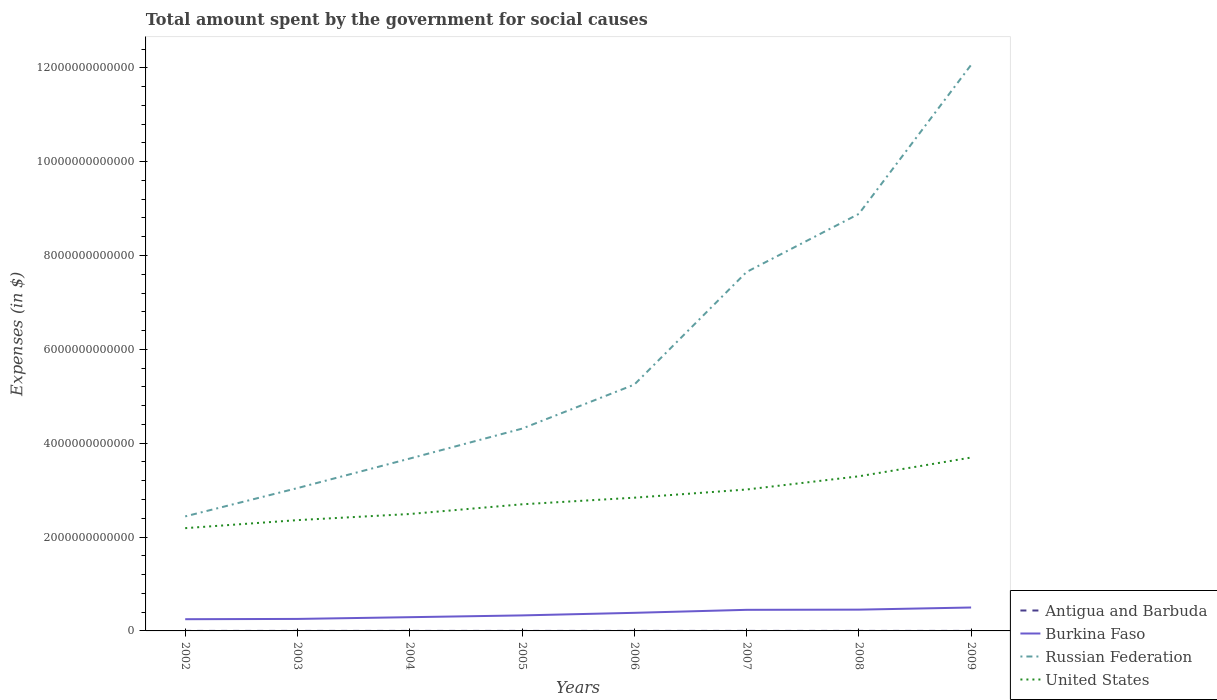How many different coloured lines are there?
Offer a very short reply. 4. Does the line corresponding to Russian Federation intersect with the line corresponding to Antigua and Barbuda?
Offer a very short reply. No. Across all years, what is the maximum amount spent for social causes by the government in Russian Federation?
Make the answer very short. 2.44e+12. What is the total amount spent for social causes by the government in United States in the graph?
Provide a short and direct response. -3.37e+11. What is the difference between the highest and the second highest amount spent for social causes by the government in Burkina Faso?
Your answer should be compact. 2.49e+11. Is the amount spent for social causes by the government in Antigua and Barbuda strictly greater than the amount spent for social causes by the government in United States over the years?
Make the answer very short. Yes. How many lines are there?
Provide a short and direct response. 4. What is the difference between two consecutive major ticks on the Y-axis?
Keep it short and to the point. 2.00e+12. Does the graph contain any zero values?
Make the answer very short. No. How many legend labels are there?
Ensure brevity in your answer.  4. How are the legend labels stacked?
Offer a terse response. Vertical. What is the title of the graph?
Keep it short and to the point. Total amount spent by the government for social causes. What is the label or title of the X-axis?
Your response must be concise. Years. What is the label or title of the Y-axis?
Your answer should be compact. Expenses (in $). What is the Expenses (in $) of Antigua and Barbuda in 2002?
Ensure brevity in your answer.  5.48e+08. What is the Expenses (in $) of Burkina Faso in 2002?
Give a very brief answer. 2.50e+11. What is the Expenses (in $) of Russian Federation in 2002?
Keep it short and to the point. 2.44e+12. What is the Expenses (in $) of United States in 2002?
Make the answer very short. 2.19e+12. What is the Expenses (in $) in Antigua and Barbuda in 2003?
Make the answer very short. 4.97e+08. What is the Expenses (in $) in Burkina Faso in 2003?
Make the answer very short. 2.56e+11. What is the Expenses (in $) in Russian Federation in 2003?
Provide a short and direct response. 3.04e+12. What is the Expenses (in $) in United States in 2003?
Offer a very short reply. 2.36e+12. What is the Expenses (in $) in Antigua and Barbuda in 2004?
Your answer should be compact. 5.53e+08. What is the Expenses (in $) of Burkina Faso in 2004?
Offer a terse response. 2.93e+11. What is the Expenses (in $) in Russian Federation in 2004?
Offer a terse response. 3.67e+12. What is the Expenses (in $) in United States in 2004?
Give a very brief answer. 2.49e+12. What is the Expenses (in $) in Antigua and Barbuda in 2005?
Your response must be concise. 5.63e+08. What is the Expenses (in $) in Burkina Faso in 2005?
Provide a succinct answer. 3.31e+11. What is the Expenses (in $) in Russian Federation in 2005?
Offer a very short reply. 4.31e+12. What is the Expenses (in $) in United States in 2005?
Provide a succinct answer. 2.70e+12. What is the Expenses (in $) in Antigua and Barbuda in 2006?
Make the answer very short. 6.84e+08. What is the Expenses (in $) of Burkina Faso in 2006?
Offer a terse response. 3.86e+11. What is the Expenses (in $) of Russian Federation in 2006?
Offer a very short reply. 5.25e+12. What is the Expenses (in $) of United States in 2006?
Give a very brief answer. 2.84e+12. What is the Expenses (in $) in Antigua and Barbuda in 2007?
Provide a short and direct response. 7.50e+08. What is the Expenses (in $) in Burkina Faso in 2007?
Give a very brief answer. 4.49e+11. What is the Expenses (in $) of Russian Federation in 2007?
Your response must be concise. 7.65e+12. What is the Expenses (in $) in United States in 2007?
Your answer should be compact. 3.01e+12. What is the Expenses (in $) in Antigua and Barbuda in 2008?
Provide a short and direct response. 7.66e+08. What is the Expenses (in $) of Burkina Faso in 2008?
Your answer should be very brief. 4.54e+11. What is the Expenses (in $) in Russian Federation in 2008?
Keep it short and to the point. 8.89e+12. What is the Expenses (in $) in United States in 2008?
Your answer should be very brief. 3.30e+12. What is the Expenses (in $) in Antigua and Barbuda in 2009?
Your response must be concise. 7.82e+08. What is the Expenses (in $) in Burkina Faso in 2009?
Provide a succinct answer. 4.99e+11. What is the Expenses (in $) of Russian Federation in 2009?
Provide a short and direct response. 1.21e+13. What is the Expenses (in $) of United States in 2009?
Make the answer very short. 3.70e+12. Across all years, what is the maximum Expenses (in $) of Antigua and Barbuda?
Provide a succinct answer. 7.82e+08. Across all years, what is the maximum Expenses (in $) in Burkina Faso?
Keep it short and to the point. 4.99e+11. Across all years, what is the maximum Expenses (in $) of Russian Federation?
Make the answer very short. 1.21e+13. Across all years, what is the maximum Expenses (in $) of United States?
Offer a terse response. 3.70e+12. Across all years, what is the minimum Expenses (in $) in Antigua and Barbuda?
Give a very brief answer. 4.97e+08. Across all years, what is the minimum Expenses (in $) in Burkina Faso?
Ensure brevity in your answer.  2.50e+11. Across all years, what is the minimum Expenses (in $) of Russian Federation?
Your response must be concise. 2.44e+12. Across all years, what is the minimum Expenses (in $) in United States?
Your answer should be compact. 2.19e+12. What is the total Expenses (in $) in Antigua and Barbuda in the graph?
Offer a very short reply. 5.14e+09. What is the total Expenses (in $) in Burkina Faso in the graph?
Make the answer very short. 2.92e+12. What is the total Expenses (in $) in Russian Federation in the graph?
Give a very brief answer. 4.73e+13. What is the total Expenses (in $) of United States in the graph?
Offer a very short reply. 2.26e+13. What is the difference between the Expenses (in $) of Antigua and Barbuda in 2002 and that in 2003?
Provide a short and direct response. 5.01e+07. What is the difference between the Expenses (in $) in Burkina Faso in 2002 and that in 2003?
Offer a very short reply. -5.97e+09. What is the difference between the Expenses (in $) of Russian Federation in 2002 and that in 2003?
Give a very brief answer. -6.03e+11. What is the difference between the Expenses (in $) in United States in 2002 and that in 2003?
Make the answer very short. -1.71e+11. What is the difference between the Expenses (in $) of Antigua and Barbuda in 2002 and that in 2004?
Give a very brief answer. -5.50e+06. What is the difference between the Expenses (in $) in Burkina Faso in 2002 and that in 2004?
Offer a very short reply. -4.28e+1. What is the difference between the Expenses (in $) in Russian Federation in 2002 and that in 2004?
Provide a short and direct response. -1.23e+12. What is the difference between the Expenses (in $) of United States in 2002 and that in 2004?
Offer a terse response. -3.02e+11. What is the difference between the Expenses (in $) in Antigua and Barbuda in 2002 and that in 2005?
Provide a short and direct response. -1.58e+07. What is the difference between the Expenses (in $) in Burkina Faso in 2002 and that in 2005?
Offer a terse response. -8.08e+1. What is the difference between the Expenses (in $) in Russian Federation in 2002 and that in 2005?
Make the answer very short. -1.87e+12. What is the difference between the Expenses (in $) of United States in 2002 and that in 2005?
Give a very brief answer. -5.08e+11. What is the difference between the Expenses (in $) in Antigua and Barbuda in 2002 and that in 2006?
Your answer should be very brief. -1.37e+08. What is the difference between the Expenses (in $) in Burkina Faso in 2002 and that in 2006?
Offer a very short reply. -1.36e+11. What is the difference between the Expenses (in $) in Russian Federation in 2002 and that in 2006?
Offer a terse response. -2.81e+12. What is the difference between the Expenses (in $) of United States in 2002 and that in 2006?
Offer a terse response. -6.49e+11. What is the difference between the Expenses (in $) of Antigua and Barbuda in 2002 and that in 2007?
Keep it short and to the point. -2.02e+08. What is the difference between the Expenses (in $) of Burkina Faso in 2002 and that in 2007?
Offer a very short reply. -2.00e+11. What is the difference between the Expenses (in $) in Russian Federation in 2002 and that in 2007?
Your response must be concise. -5.21e+12. What is the difference between the Expenses (in $) in United States in 2002 and that in 2007?
Your answer should be very brief. -8.24e+11. What is the difference between the Expenses (in $) in Antigua and Barbuda in 2002 and that in 2008?
Your answer should be compact. -2.19e+08. What is the difference between the Expenses (in $) in Burkina Faso in 2002 and that in 2008?
Your answer should be very brief. -2.04e+11. What is the difference between the Expenses (in $) of Russian Federation in 2002 and that in 2008?
Offer a terse response. -6.45e+12. What is the difference between the Expenses (in $) in United States in 2002 and that in 2008?
Offer a terse response. -1.11e+12. What is the difference between the Expenses (in $) of Antigua and Barbuda in 2002 and that in 2009?
Offer a very short reply. -2.34e+08. What is the difference between the Expenses (in $) of Burkina Faso in 2002 and that in 2009?
Provide a short and direct response. -2.49e+11. What is the difference between the Expenses (in $) of Russian Federation in 2002 and that in 2009?
Keep it short and to the point. -9.62e+12. What is the difference between the Expenses (in $) in United States in 2002 and that in 2009?
Your answer should be compact. -1.50e+12. What is the difference between the Expenses (in $) in Antigua and Barbuda in 2003 and that in 2004?
Give a very brief answer. -5.56e+07. What is the difference between the Expenses (in $) of Burkina Faso in 2003 and that in 2004?
Provide a short and direct response. -3.68e+1. What is the difference between the Expenses (in $) of Russian Federation in 2003 and that in 2004?
Your response must be concise. -6.29e+11. What is the difference between the Expenses (in $) of United States in 2003 and that in 2004?
Provide a short and direct response. -1.30e+11. What is the difference between the Expenses (in $) in Antigua and Barbuda in 2003 and that in 2005?
Offer a terse response. -6.59e+07. What is the difference between the Expenses (in $) in Burkina Faso in 2003 and that in 2005?
Offer a very short reply. -7.48e+1. What is the difference between the Expenses (in $) in Russian Federation in 2003 and that in 2005?
Provide a short and direct response. -1.27e+12. What is the difference between the Expenses (in $) in United States in 2003 and that in 2005?
Your answer should be very brief. -3.37e+11. What is the difference between the Expenses (in $) in Antigua and Barbuda in 2003 and that in 2006?
Provide a short and direct response. -1.87e+08. What is the difference between the Expenses (in $) in Burkina Faso in 2003 and that in 2006?
Your answer should be compact. -1.30e+11. What is the difference between the Expenses (in $) in Russian Federation in 2003 and that in 2006?
Your answer should be very brief. -2.20e+12. What is the difference between the Expenses (in $) of United States in 2003 and that in 2006?
Provide a succinct answer. -4.78e+11. What is the difference between the Expenses (in $) in Antigua and Barbuda in 2003 and that in 2007?
Keep it short and to the point. -2.52e+08. What is the difference between the Expenses (in $) in Burkina Faso in 2003 and that in 2007?
Your answer should be compact. -1.94e+11. What is the difference between the Expenses (in $) in Russian Federation in 2003 and that in 2007?
Your response must be concise. -4.61e+12. What is the difference between the Expenses (in $) of United States in 2003 and that in 2007?
Offer a very short reply. -6.53e+11. What is the difference between the Expenses (in $) of Antigua and Barbuda in 2003 and that in 2008?
Ensure brevity in your answer.  -2.69e+08. What is the difference between the Expenses (in $) of Burkina Faso in 2003 and that in 2008?
Offer a terse response. -1.98e+11. What is the difference between the Expenses (in $) in Russian Federation in 2003 and that in 2008?
Your answer should be very brief. -5.84e+12. What is the difference between the Expenses (in $) of United States in 2003 and that in 2008?
Offer a terse response. -9.34e+11. What is the difference between the Expenses (in $) of Antigua and Barbuda in 2003 and that in 2009?
Your answer should be compact. -2.84e+08. What is the difference between the Expenses (in $) in Burkina Faso in 2003 and that in 2009?
Offer a very short reply. -2.43e+11. What is the difference between the Expenses (in $) of Russian Federation in 2003 and that in 2009?
Make the answer very short. -9.02e+12. What is the difference between the Expenses (in $) of United States in 2003 and that in 2009?
Provide a short and direct response. -1.33e+12. What is the difference between the Expenses (in $) in Antigua and Barbuda in 2004 and that in 2005?
Offer a terse response. -1.03e+07. What is the difference between the Expenses (in $) of Burkina Faso in 2004 and that in 2005?
Offer a very short reply. -3.80e+1. What is the difference between the Expenses (in $) of Russian Federation in 2004 and that in 2005?
Make the answer very short. -6.37e+11. What is the difference between the Expenses (in $) in United States in 2004 and that in 2005?
Offer a very short reply. -2.07e+11. What is the difference between the Expenses (in $) of Antigua and Barbuda in 2004 and that in 2006?
Offer a very short reply. -1.31e+08. What is the difference between the Expenses (in $) in Burkina Faso in 2004 and that in 2006?
Provide a short and direct response. -9.30e+1. What is the difference between the Expenses (in $) in Russian Federation in 2004 and that in 2006?
Provide a short and direct response. -1.58e+12. What is the difference between the Expenses (in $) in United States in 2004 and that in 2006?
Your response must be concise. -3.48e+11. What is the difference between the Expenses (in $) in Antigua and Barbuda in 2004 and that in 2007?
Provide a short and direct response. -1.97e+08. What is the difference between the Expenses (in $) in Burkina Faso in 2004 and that in 2007?
Your response must be concise. -1.57e+11. What is the difference between the Expenses (in $) of Russian Federation in 2004 and that in 2007?
Your answer should be very brief. -3.98e+12. What is the difference between the Expenses (in $) of United States in 2004 and that in 2007?
Offer a very short reply. -5.22e+11. What is the difference between the Expenses (in $) of Antigua and Barbuda in 2004 and that in 2008?
Provide a short and direct response. -2.13e+08. What is the difference between the Expenses (in $) of Burkina Faso in 2004 and that in 2008?
Provide a succinct answer. -1.61e+11. What is the difference between the Expenses (in $) of Russian Federation in 2004 and that in 2008?
Make the answer very short. -5.21e+12. What is the difference between the Expenses (in $) of United States in 2004 and that in 2008?
Your answer should be very brief. -8.04e+11. What is the difference between the Expenses (in $) of Antigua and Barbuda in 2004 and that in 2009?
Provide a succinct answer. -2.29e+08. What is the difference between the Expenses (in $) in Burkina Faso in 2004 and that in 2009?
Make the answer very short. -2.06e+11. What is the difference between the Expenses (in $) of Russian Federation in 2004 and that in 2009?
Offer a very short reply. -8.39e+12. What is the difference between the Expenses (in $) in United States in 2004 and that in 2009?
Ensure brevity in your answer.  -1.20e+12. What is the difference between the Expenses (in $) in Antigua and Barbuda in 2005 and that in 2006?
Give a very brief answer. -1.21e+08. What is the difference between the Expenses (in $) of Burkina Faso in 2005 and that in 2006?
Your response must be concise. -5.50e+1. What is the difference between the Expenses (in $) of Russian Federation in 2005 and that in 2006?
Make the answer very short. -9.38e+11. What is the difference between the Expenses (in $) in United States in 2005 and that in 2006?
Your answer should be compact. -1.41e+11. What is the difference between the Expenses (in $) of Antigua and Barbuda in 2005 and that in 2007?
Provide a short and direct response. -1.86e+08. What is the difference between the Expenses (in $) in Burkina Faso in 2005 and that in 2007?
Your response must be concise. -1.19e+11. What is the difference between the Expenses (in $) in Russian Federation in 2005 and that in 2007?
Offer a terse response. -3.34e+12. What is the difference between the Expenses (in $) in United States in 2005 and that in 2007?
Keep it short and to the point. -3.15e+11. What is the difference between the Expenses (in $) of Antigua and Barbuda in 2005 and that in 2008?
Offer a terse response. -2.03e+08. What is the difference between the Expenses (in $) of Burkina Faso in 2005 and that in 2008?
Ensure brevity in your answer.  -1.23e+11. What is the difference between the Expenses (in $) in Russian Federation in 2005 and that in 2008?
Give a very brief answer. -4.58e+12. What is the difference between the Expenses (in $) of United States in 2005 and that in 2008?
Provide a short and direct response. -5.97e+11. What is the difference between the Expenses (in $) of Antigua and Barbuda in 2005 and that in 2009?
Give a very brief answer. -2.18e+08. What is the difference between the Expenses (in $) of Burkina Faso in 2005 and that in 2009?
Offer a terse response. -1.68e+11. What is the difference between the Expenses (in $) of Russian Federation in 2005 and that in 2009?
Give a very brief answer. -7.75e+12. What is the difference between the Expenses (in $) in United States in 2005 and that in 2009?
Your answer should be very brief. -9.97e+11. What is the difference between the Expenses (in $) of Antigua and Barbuda in 2006 and that in 2007?
Ensure brevity in your answer.  -6.55e+07. What is the difference between the Expenses (in $) in Burkina Faso in 2006 and that in 2007?
Your answer should be very brief. -6.37e+1. What is the difference between the Expenses (in $) in Russian Federation in 2006 and that in 2007?
Offer a very short reply. -2.40e+12. What is the difference between the Expenses (in $) in United States in 2006 and that in 2007?
Make the answer very short. -1.74e+11. What is the difference between the Expenses (in $) of Antigua and Barbuda in 2006 and that in 2008?
Ensure brevity in your answer.  -8.22e+07. What is the difference between the Expenses (in $) in Burkina Faso in 2006 and that in 2008?
Offer a terse response. -6.80e+1. What is the difference between the Expenses (in $) in Russian Federation in 2006 and that in 2008?
Give a very brief answer. -3.64e+12. What is the difference between the Expenses (in $) of United States in 2006 and that in 2008?
Your answer should be very brief. -4.56e+11. What is the difference between the Expenses (in $) in Antigua and Barbuda in 2006 and that in 2009?
Provide a succinct answer. -9.76e+07. What is the difference between the Expenses (in $) in Burkina Faso in 2006 and that in 2009?
Ensure brevity in your answer.  -1.13e+11. What is the difference between the Expenses (in $) in Russian Federation in 2006 and that in 2009?
Your response must be concise. -6.81e+12. What is the difference between the Expenses (in $) in United States in 2006 and that in 2009?
Offer a very short reply. -8.56e+11. What is the difference between the Expenses (in $) of Antigua and Barbuda in 2007 and that in 2008?
Your answer should be compact. -1.67e+07. What is the difference between the Expenses (in $) in Burkina Faso in 2007 and that in 2008?
Provide a succinct answer. -4.22e+09. What is the difference between the Expenses (in $) of Russian Federation in 2007 and that in 2008?
Your answer should be very brief. -1.24e+12. What is the difference between the Expenses (in $) in United States in 2007 and that in 2008?
Your answer should be compact. -2.81e+11. What is the difference between the Expenses (in $) in Antigua and Barbuda in 2007 and that in 2009?
Keep it short and to the point. -3.21e+07. What is the difference between the Expenses (in $) in Burkina Faso in 2007 and that in 2009?
Offer a terse response. -4.97e+1. What is the difference between the Expenses (in $) in Russian Federation in 2007 and that in 2009?
Offer a terse response. -4.41e+12. What is the difference between the Expenses (in $) in United States in 2007 and that in 2009?
Provide a succinct answer. -6.81e+11. What is the difference between the Expenses (in $) of Antigua and Barbuda in 2008 and that in 2009?
Your answer should be very brief. -1.54e+07. What is the difference between the Expenses (in $) of Burkina Faso in 2008 and that in 2009?
Your answer should be very brief. -4.54e+1. What is the difference between the Expenses (in $) in Russian Federation in 2008 and that in 2009?
Provide a succinct answer. -3.18e+12. What is the difference between the Expenses (in $) in United States in 2008 and that in 2009?
Make the answer very short. -4.00e+11. What is the difference between the Expenses (in $) of Antigua and Barbuda in 2002 and the Expenses (in $) of Burkina Faso in 2003?
Ensure brevity in your answer.  -2.55e+11. What is the difference between the Expenses (in $) in Antigua and Barbuda in 2002 and the Expenses (in $) in Russian Federation in 2003?
Offer a very short reply. -3.04e+12. What is the difference between the Expenses (in $) in Antigua and Barbuda in 2002 and the Expenses (in $) in United States in 2003?
Your answer should be very brief. -2.36e+12. What is the difference between the Expenses (in $) in Burkina Faso in 2002 and the Expenses (in $) in Russian Federation in 2003?
Offer a very short reply. -2.79e+12. What is the difference between the Expenses (in $) of Burkina Faso in 2002 and the Expenses (in $) of United States in 2003?
Offer a very short reply. -2.11e+12. What is the difference between the Expenses (in $) of Russian Federation in 2002 and the Expenses (in $) of United States in 2003?
Your answer should be very brief. 7.95e+1. What is the difference between the Expenses (in $) of Antigua and Barbuda in 2002 and the Expenses (in $) of Burkina Faso in 2004?
Your answer should be very brief. -2.92e+11. What is the difference between the Expenses (in $) in Antigua and Barbuda in 2002 and the Expenses (in $) in Russian Federation in 2004?
Provide a short and direct response. -3.67e+12. What is the difference between the Expenses (in $) of Antigua and Barbuda in 2002 and the Expenses (in $) of United States in 2004?
Your answer should be compact. -2.49e+12. What is the difference between the Expenses (in $) of Burkina Faso in 2002 and the Expenses (in $) of Russian Federation in 2004?
Ensure brevity in your answer.  -3.42e+12. What is the difference between the Expenses (in $) of Burkina Faso in 2002 and the Expenses (in $) of United States in 2004?
Provide a succinct answer. -2.24e+12. What is the difference between the Expenses (in $) of Russian Federation in 2002 and the Expenses (in $) of United States in 2004?
Keep it short and to the point. -5.10e+1. What is the difference between the Expenses (in $) in Antigua and Barbuda in 2002 and the Expenses (in $) in Burkina Faso in 2005?
Keep it short and to the point. -3.30e+11. What is the difference between the Expenses (in $) of Antigua and Barbuda in 2002 and the Expenses (in $) of Russian Federation in 2005?
Ensure brevity in your answer.  -4.31e+12. What is the difference between the Expenses (in $) of Antigua and Barbuda in 2002 and the Expenses (in $) of United States in 2005?
Offer a terse response. -2.70e+12. What is the difference between the Expenses (in $) of Burkina Faso in 2002 and the Expenses (in $) of Russian Federation in 2005?
Your response must be concise. -4.06e+12. What is the difference between the Expenses (in $) in Burkina Faso in 2002 and the Expenses (in $) in United States in 2005?
Offer a terse response. -2.45e+12. What is the difference between the Expenses (in $) of Russian Federation in 2002 and the Expenses (in $) of United States in 2005?
Keep it short and to the point. -2.58e+11. What is the difference between the Expenses (in $) in Antigua and Barbuda in 2002 and the Expenses (in $) in Burkina Faso in 2006?
Keep it short and to the point. -3.85e+11. What is the difference between the Expenses (in $) in Antigua and Barbuda in 2002 and the Expenses (in $) in Russian Federation in 2006?
Keep it short and to the point. -5.25e+12. What is the difference between the Expenses (in $) of Antigua and Barbuda in 2002 and the Expenses (in $) of United States in 2006?
Make the answer very short. -2.84e+12. What is the difference between the Expenses (in $) in Burkina Faso in 2002 and the Expenses (in $) in Russian Federation in 2006?
Provide a short and direct response. -5.00e+12. What is the difference between the Expenses (in $) of Burkina Faso in 2002 and the Expenses (in $) of United States in 2006?
Provide a succinct answer. -2.59e+12. What is the difference between the Expenses (in $) in Russian Federation in 2002 and the Expenses (in $) in United States in 2006?
Make the answer very short. -3.99e+11. What is the difference between the Expenses (in $) in Antigua and Barbuda in 2002 and the Expenses (in $) in Burkina Faso in 2007?
Ensure brevity in your answer.  -4.49e+11. What is the difference between the Expenses (in $) of Antigua and Barbuda in 2002 and the Expenses (in $) of Russian Federation in 2007?
Keep it short and to the point. -7.65e+12. What is the difference between the Expenses (in $) of Antigua and Barbuda in 2002 and the Expenses (in $) of United States in 2007?
Offer a very short reply. -3.01e+12. What is the difference between the Expenses (in $) of Burkina Faso in 2002 and the Expenses (in $) of Russian Federation in 2007?
Provide a succinct answer. -7.40e+12. What is the difference between the Expenses (in $) of Burkina Faso in 2002 and the Expenses (in $) of United States in 2007?
Your response must be concise. -2.76e+12. What is the difference between the Expenses (in $) in Russian Federation in 2002 and the Expenses (in $) in United States in 2007?
Offer a very short reply. -5.73e+11. What is the difference between the Expenses (in $) of Antigua and Barbuda in 2002 and the Expenses (in $) of Burkina Faso in 2008?
Provide a short and direct response. -4.53e+11. What is the difference between the Expenses (in $) of Antigua and Barbuda in 2002 and the Expenses (in $) of Russian Federation in 2008?
Your answer should be compact. -8.89e+12. What is the difference between the Expenses (in $) of Antigua and Barbuda in 2002 and the Expenses (in $) of United States in 2008?
Your answer should be very brief. -3.29e+12. What is the difference between the Expenses (in $) in Burkina Faso in 2002 and the Expenses (in $) in Russian Federation in 2008?
Your response must be concise. -8.64e+12. What is the difference between the Expenses (in $) in Burkina Faso in 2002 and the Expenses (in $) in United States in 2008?
Ensure brevity in your answer.  -3.05e+12. What is the difference between the Expenses (in $) of Russian Federation in 2002 and the Expenses (in $) of United States in 2008?
Offer a terse response. -8.55e+11. What is the difference between the Expenses (in $) in Antigua and Barbuda in 2002 and the Expenses (in $) in Burkina Faso in 2009?
Keep it short and to the point. -4.99e+11. What is the difference between the Expenses (in $) in Antigua and Barbuda in 2002 and the Expenses (in $) in Russian Federation in 2009?
Offer a very short reply. -1.21e+13. What is the difference between the Expenses (in $) of Antigua and Barbuda in 2002 and the Expenses (in $) of United States in 2009?
Provide a succinct answer. -3.69e+12. What is the difference between the Expenses (in $) of Burkina Faso in 2002 and the Expenses (in $) of Russian Federation in 2009?
Make the answer very short. -1.18e+13. What is the difference between the Expenses (in $) in Burkina Faso in 2002 and the Expenses (in $) in United States in 2009?
Keep it short and to the point. -3.45e+12. What is the difference between the Expenses (in $) in Russian Federation in 2002 and the Expenses (in $) in United States in 2009?
Provide a succinct answer. -1.25e+12. What is the difference between the Expenses (in $) of Antigua and Barbuda in 2003 and the Expenses (in $) of Burkina Faso in 2004?
Offer a very short reply. -2.92e+11. What is the difference between the Expenses (in $) in Antigua and Barbuda in 2003 and the Expenses (in $) in Russian Federation in 2004?
Provide a succinct answer. -3.67e+12. What is the difference between the Expenses (in $) of Antigua and Barbuda in 2003 and the Expenses (in $) of United States in 2004?
Offer a very short reply. -2.49e+12. What is the difference between the Expenses (in $) in Burkina Faso in 2003 and the Expenses (in $) in Russian Federation in 2004?
Provide a succinct answer. -3.42e+12. What is the difference between the Expenses (in $) of Burkina Faso in 2003 and the Expenses (in $) of United States in 2004?
Your answer should be very brief. -2.24e+12. What is the difference between the Expenses (in $) of Russian Federation in 2003 and the Expenses (in $) of United States in 2004?
Provide a succinct answer. 5.52e+11. What is the difference between the Expenses (in $) of Antigua and Barbuda in 2003 and the Expenses (in $) of Burkina Faso in 2005?
Make the answer very short. -3.30e+11. What is the difference between the Expenses (in $) of Antigua and Barbuda in 2003 and the Expenses (in $) of Russian Federation in 2005?
Your answer should be very brief. -4.31e+12. What is the difference between the Expenses (in $) of Antigua and Barbuda in 2003 and the Expenses (in $) of United States in 2005?
Give a very brief answer. -2.70e+12. What is the difference between the Expenses (in $) in Burkina Faso in 2003 and the Expenses (in $) in Russian Federation in 2005?
Your response must be concise. -4.05e+12. What is the difference between the Expenses (in $) of Burkina Faso in 2003 and the Expenses (in $) of United States in 2005?
Ensure brevity in your answer.  -2.44e+12. What is the difference between the Expenses (in $) of Russian Federation in 2003 and the Expenses (in $) of United States in 2005?
Ensure brevity in your answer.  3.46e+11. What is the difference between the Expenses (in $) in Antigua and Barbuda in 2003 and the Expenses (in $) in Burkina Faso in 2006?
Your response must be concise. -3.85e+11. What is the difference between the Expenses (in $) of Antigua and Barbuda in 2003 and the Expenses (in $) of Russian Federation in 2006?
Provide a short and direct response. -5.25e+12. What is the difference between the Expenses (in $) of Antigua and Barbuda in 2003 and the Expenses (in $) of United States in 2006?
Give a very brief answer. -2.84e+12. What is the difference between the Expenses (in $) of Burkina Faso in 2003 and the Expenses (in $) of Russian Federation in 2006?
Provide a short and direct response. -4.99e+12. What is the difference between the Expenses (in $) in Burkina Faso in 2003 and the Expenses (in $) in United States in 2006?
Give a very brief answer. -2.58e+12. What is the difference between the Expenses (in $) in Russian Federation in 2003 and the Expenses (in $) in United States in 2006?
Your response must be concise. 2.05e+11. What is the difference between the Expenses (in $) of Antigua and Barbuda in 2003 and the Expenses (in $) of Burkina Faso in 2007?
Give a very brief answer. -4.49e+11. What is the difference between the Expenses (in $) in Antigua and Barbuda in 2003 and the Expenses (in $) in Russian Federation in 2007?
Ensure brevity in your answer.  -7.65e+12. What is the difference between the Expenses (in $) in Antigua and Barbuda in 2003 and the Expenses (in $) in United States in 2007?
Offer a terse response. -3.01e+12. What is the difference between the Expenses (in $) in Burkina Faso in 2003 and the Expenses (in $) in Russian Federation in 2007?
Ensure brevity in your answer.  -7.39e+12. What is the difference between the Expenses (in $) of Burkina Faso in 2003 and the Expenses (in $) of United States in 2007?
Your response must be concise. -2.76e+12. What is the difference between the Expenses (in $) in Russian Federation in 2003 and the Expenses (in $) in United States in 2007?
Give a very brief answer. 3.02e+1. What is the difference between the Expenses (in $) in Antigua and Barbuda in 2003 and the Expenses (in $) in Burkina Faso in 2008?
Keep it short and to the point. -4.53e+11. What is the difference between the Expenses (in $) in Antigua and Barbuda in 2003 and the Expenses (in $) in Russian Federation in 2008?
Provide a succinct answer. -8.89e+12. What is the difference between the Expenses (in $) in Antigua and Barbuda in 2003 and the Expenses (in $) in United States in 2008?
Your response must be concise. -3.29e+12. What is the difference between the Expenses (in $) in Burkina Faso in 2003 and the Expenses (in $) in Russian Federation in 2008?
Your response must be concise. -8.63e+12. What is the difference between the Expenses (in $) in Burkina Faso in 2003 and the Expenses (in $) in United States in 2008?
Your answer should be compact. -3.04e+12. What is the difference between the Expenses (in $) in Russian Federation in 2003 and the Expenses (in $) in United States in 2008?
Give a very brief answer. -2.51e+11. What is the difference between the Expenses (in $) of Antigua and Barbuda in 2003 and the Expenses (in $) of Burkina Faso in 2009?
Your response must be concise. -4.99e+11. What is the difference between the Expenses (in $) in Antigua and Barbuda in 2003 and the Expenses (in $) in Russian Federation in 2009?
Ensure brevity in your answer.  -1.21e+13. What is the difference between the Expenses (in $) in Antigua and Barbuda in 2003 and the Expenses (in $) in United States in 2009?
Keep it short and to the point. -3.69e+12. What is the difference between the Expenses (in $) of Burkina Faso in 2003 and the Expenses (in $) of Russian Federation in 2009?
Give a very brief answer. -1.18e+13. What is the difference between the Expenses (in $) of Burkina Faso in 2003 and the Expenses (in $) of United States in 2009?
Your answer should be very brief. -3.44e+12. What is the difference between the Expenses (in $) in Russian Federation in 2003 and the Expenses (in $) in United States in 2009?
Your response must be concise. -6.51e+11. What is the difference between the Expenses (in $) of Antigua and Barbuda in 2004 and the Expenses (in $) of Burkina Faso in 2005?
Your response must be concise. -3.30e+11. What is the difference between the Expenses (in $) of Antigua and Barbuda in 2004 and the Expenses (in $) of Russian Federation in 2005?
Offer a very short reply. -4.31e+12. What is the difference between the Expenses (in $) in Antigua and Barbuda in 2004 and the Expenses (in $) in United States in 2005?
Ensure brevity in your answer.  -2.70e+12. What is the difference between the Expenses (in $) in Burkina Faso in 2004 and the Expenses (in $) in Russian Federation in 2005?
Your response must be concise. -4.02e+12. What is the difference between the Expenses (in $) of Burkina Faso in 2004 and the Expenses (in $) of United States in 2005?
Your response must be concise. -2.41e+12. What is the difference between the Expenses (in $) of Russian Federation in 2004 and the Expenses (in $) of United States in 2005?
Your response must be concise. 9.75e+11. What is the difference between the Expenses (in $) in Antigua and Barbuda in 2004 and the Expenses (in $) in Burkina Faso in 2006?
Your answer should be very brief. -3.85e+11. What is the difference between the Expenses (in $) of Antigua and Barbuda in 2004 and the Expenses (in $) of Russian Federation in 2006?
Offer a very short reply. -5.25e+12. What is the difference between the Expenses (in $) in Antigua and Barbuda in 2004 and the Expenses (in $) in United States in 2006?
Give a very brief answer. -2.84e+12. What is the difference between the Expenses (in $) of Burkina Faso in 2004 and the Expenses (in $) of Russian Federation in 2006?
Offer a terse response. -4.96e+12. What is the difference between the Expenses (in $) of Burkina Faso in 2004 and the Expenses (in $) of United States in 2006?
Your response must be concise. -2.55e+12. What is the difference between the Expenses (in $) in Russian Federation in 2004 and the Expenses (in $) in United States in 2006?
Provide a succinct answer. 8.34e+11. What is the difference between the Expenses (in $) of Antigua and Barbuda in 2004 and the Expenses (in $) of Burkina Faso in 2007?
Provide a succinct answer. -4.49e+11. What is the difference between the Expenses (in $) of Antigua and Barbuda in 2004 and the Expenses (in $) of Russian Federation in 2007?
Give a very brief answer. -7.65e+12. What is the difference between the Expenses (in $) of Antigua and Barbuda in 2004 and the Expenses (in $) of United States in 2007?
Your answer should be very brief. -3.01e+12. What is the difference between the Expenses (in $) of Burkina Faso in 2004 and the Expenses (in $) of Russian Federation in 2007?
Provide a succinct answer. -7.36e+12. What is the difference between the Expenses (in $) in Burkina Faso in 2004 and the Expenses (in $) in United States in 2007?
Ensure brevity in your answer.  -2.72e+12. What is the difference between the Expenses (in $) of Russian Federation in 2004 and the Expenses (in $) of United States in 2007?
Provide a succinct answer. 6.60e+11. What is the difference between the Expenses (in $) of Antigua and Barbuda in 2004 and the Expenses (in $) of Burkina Faso in 2008?
Offer a very short reply. -4.53e+11. What is the difference between the Expenses (in $) of Antigua and Barbuda in 2004 and the Expenses (in $) of Russian Federation in 2008?
Offer a terse response. -8.89e+12. What is the difference between the Expenses (in $) of Antigua and Barbuda in 2004 and the Expenses (in $) of United States in 2008?
Provide a short and direct response. -3.29e+12. What is the difference between the Expenses (in $) in Burkina Faso in 2004 and the Expenses (in $) in Russian Federation in 2008?
Give a very brief answer. -8.60e+12. What is the difference between the Expenses (in $) in Burkina Faso in 2004 and the Expenses (in $) in United States in 2008?
Your response must be concise. -3.00e+12. What is the difference between the Expenses (in $) of Russian Federation in 2004 and the Expenses (in $) of United States in 2008?
Ensure brevity in your answer.  3.78e+11. What is the difference between the Expenses (in $) in Antigua and Barbuda in 2004 and the Expenses (in $) in Burkina Faso in 2009?
Your answer should be very brief. -4.99e+11. What is the difference between the Expenses (in $) of Antigua and Barbuda in 2004 and the Expenses (in $) of Russian Federation in 2009?
Keep it short and to the point. -1.21e+13. What is the difference between the Expenses (in $) in Antigua and Barbuda in 2004 and the Expenses (in $) in United States in 2009?
Provide a succinct answer. -3.69e+12. What is the difference between the Expenses (in $) in Burkina Faso in 2004 and the Expenses (in $) in Russian Federation in 2009?
Provide a succinct answer. -1.18e+13. What is the difference between the Expenses (in $) in Burkina Faso in 2004 and the Expenses (in $) in United States in 2009?
Your response must be concise. -3.40e+12. What is the difference between the Expenses (in $) of Russian Federation in 2004 and the Expenses (in $) of United States in 2009?
Offer a terse response. -2.16e+1. What is the difference between the Expenses (in $) of Antigua and Barbuda in 2005 and the Expenses (in $) of Burkina Faso in 2006?
Provide a short and direct response. -3.85e+11. What is the difference between the Expenses (in $) of Antigua and Barbuda in 2005 and the Expenses (in $) of Russian Federation in 2006?
Ensure brevity in your answer.  -5.25e+12. What is the difference between the Expenses (in $) in Antigua and Barbuda in 2005 and the Expenses (in $) in United States in 2006?
Keep it short and to the point. -2.84e+12. What is the difference between the Expenses (in $) in Burkina Faso in 2005 and the Expenses (in $) in Russian Federation in 2006?
Provide a short and direct response. -4.92e+12. What is the difference between the Expenses (in $) in Burkina Faso in 2005 and the Expenses (in $) in United States in 2006?
Offer a very short reply. -2.51e+12. What is the difference between the Expenses (in $) in Russian Federation in 2005 and the Expenses (in $) in United States in 2006?
Your response must be concise. 1.47e+12. What is the difference between the Expenses (in $) in Antigua and Barbuda in 2005 and the Expenses (in $) in Burkina Faso in 2007?
Give a very brief answer. -4.49e+11. What is the difference between the Expenses (in $) of Antigua and Barbuda in 2005 and the Expenses (in $) of Russian Federation in 2007?
Give a very brief answer. -7.65e+12. What is the difference between the Expenses (in $) of Antigua and Barbuda in 2005 and the Expenses (in $) of United States in 2007?
Provide a short and direct response. -3.01e+12. What is the difference between the Expenses (in $) in Burkina Faso in 2005 and the Expenses (in $) in Russian Federation in 2007?
Your response must be concise. -7.32e+12. What is the difference between the Expenses (in $) in Burkina Faso in 2005 and the Expenses (in $) in United States in 2007?
Offer a terse response. -2.68e+12. What is the difference between the Expenses (in $) of Russian Federation in 2005 and the Expenses (in $) of United States in 2007?
Ensure brevity in your answer.  1.30e+12. What is the difference between the Expenses (in $) of Antigua and Barbuda in 2005 and the Expenses (in $) of Burkina Faso in 2008?
Provide a short and direct response. -4.53e+11. What is the difference between the Expenses (in $) in Antigua and Barbuda in 2005 and the Expenses (in $) in Russian Federation in 2008?
Your response must be concise. -8.89e+12. What is the difference between the Expenses (in $) in Antigua and Barbuda in 2005 and the Expenses (in $) in United States in 2008?
Provide a short and direct response. -3.29e+12. What is the difference between the Expenses (in $) in Burkina Faso in 2005 and the Expenses (in $) in Russian Federation in 2008?
Your answer should be very brief. -8.56e+12. What is the difference between the Expenses (in $) in Burkina Faso in 2005 and the Expenses (in $) in United States in 2008?
Make the answer very short. -2.96e+12. What is the difference between the Expenses (in $) in Russian Federation in 2005 and the Expenses (in $) in United States in 2008?
Ensure brevity in your answer.  1.02e+12. What is the difference between the Expenses (in $) in Antigua and Barbuda in 2005 and the Expenses (in $) in Burkina Faso in 2009?
Offer a very short reply. -4.99e+11. What is the difference between the Expenses (in $) in Antigua and Barbuda in 2005 and the Expenses (in $) in Russian Federation in 2009?
Ensure brevity in your answer.  -1.21e+13. What is the difference between the Expenses (in $) of Antigua and Barbuda in 2005 and the Expenses (in $) of United States in 2009?
Offer a terse response. -3.69e+12. What is the difference between the Expenses (in $) of Burkina Faso in 2005 and the Expenses (in $) of Russian Federation in 2009?
Provide a short and direct response. -1.17e+13. What is the difference between the Expenses (in $) in Burkina Faso in 2005 and the Expenses (in $) in United States in 2009?
Your answer should be compact. -3.36e+12. What is the difference between the Expenses (in $) of Russian Federation in 2005 and the Expenses (in $) of United States in 2009?
Your answer should be very brief. 6.16e+11. What is the difference between the Expenses (in $) of Antigua and Barbuda in 2006 and the Expenses (in $) of Burkina Faso in 2007?
Make the answer very short. -4.49e+11. What is the difference between the Expenses (in $) in Antigua and Barbuda in 2006 and the Expenses (in $) in Russian Federation in 2007?
Provide a short and direct response. -7.65e+12. What is the difference between the Expenses (in $) of Antigua and Barbuda in 2006 and the Expenses (in $) of United States in 2007?
Ensure brevity in your answer.  -3.01e+12. What is the difference between the Expenses (in $) of Burkina Faso in 2006 and the Expenses (in $) of Russian Federation in 2007?
Keep it short and to the point. -7.26e+12. What is the difference between the Expenses (in $) of Burkina Faso in 2006 and the Expenses (in $) of United States in 2007?
Provide a succinct answer. -2.63e+12. What is the difference between the Expenses (in $) in Russian Federation in 2006 and the Expenses (in $) in United States in 2007?
Your answer should be compact. 2.24e+12. What is the difference between the Expenses (in $) of Antigua and Barbuda in 2006 and the Expenses (in $) of Burkina Faso in 2008?
Provide a succinct answer. -4.53e+11. What is the difference between the Expenses (in $) of Antigua and Barbuda in 2006 and the Expenses (in $) of Russian Federation in 2008?
Your response must be concise. -8.89e+12. What is the difference between the Expenses (in $) of Antigua and Barbuda in 2006 and the Expenses (in $) of United States in 2008?
Your response must be concise. -3.29e+12. What is the difference between the Expenses (in $) of Burkina Faso in 2006 and the Expenses (in $) of Russian Federation in 2008?
Your answer should be compact. -8.50e+12. What is the difference between the Expenses (in $) of Burkina Faso in 2006 and the Expenses (in $) of United States in 2008?
Give a very brief answer. -2.91e+12. What is the difference between the Expenses (in $) of Russian Federation in 2006 and the Expenses (in $) of United States in 2008?
Your response must be concise. 1.95e+12. What is the difference between the Expenses (in $) in Antigua and Barbuda in 2006 and the Expenses (in $) in Burkina Faso in 2009?
Make the answer very short. -4.98e+11. What is the difference between the Expenses (in $) of Antigua and Barbuda in 2006 and the Expenses (in $) of Russian Federation in 2009?
Give a very brief answer. -1.21e+13. What is the difference between the Expenses (in $) in Antigua and Barbuda in 2006 and the Expenses (in $) in United States in 2009?
Provide a succinct answer. -3.69e+12. What is the difference between the Expenses (in $) in Burkina Faso in 2006 and the Expenses (in $) in Russian Federation in 2009?
Your response must be concise. -1.17e+13. What is the difference between the Expenses (in $) of Burkina Faso in 2006 and the Expenses (in $) of United States in 2009?
Offer a terse response. -3.31e+12. What is the difference between the Expenses (in $) of Russian Federation in 2006 and the Expenses (in $) of United States in 2009?
Your answer should be compact. 1.55e+12. What is the difference between the Expenses (in $) in Antigua and Barbuda in 2007 and the Expenses (in $) in Burkina Faso in 2008?
Provide a succinct answer. -4.53e+11. What is the difference between the Expenses (in $) of Antigua and Barbuda in 2007 and the Expenses (in $) of Russian Federation in 2008?
Give a very brief answer. -8.89e+12. What is the difference between the Expenses (in $) of Antigua and Barbuda in 2007 and the Expenses (in $) of United States in 2008?
Keep it short and to the point. -3.29e+12. What is the difference between the Expenses (in $) of Burkina Faso in 2007 and the Expenses (in $) of Russian Federation in 2008?
Ensure brevity in your answer.  -8.44e+12. What is the difference between the Expenses (in $) in Burkina Faso in 2007 and the Expenses (in $) in United States in 2008?
Make the answer very short. -2.85e+12. What is the difference between the Expenses (in $) in Russian Federation in 2007 and the Expenses (in $) in United States in 2008?
Offer a terse response. 4.35e+12. What is the difference between the Expenses (in $) of Antigua and Barbuda in 2007 and the Expenses (in $) of Burkina Faso in 2009?
Make the answer very short. -4.98e+11. What is the difference between the Expenses (in $) of Antigua and Barbuda in 2007 and the Expenses (in $) of Russian Federation in 2009?
Keep it short and to the point. -1.21e+13. What is the difference between the Expenses (in $) in Antigua and Barbuda in 2007 and the Expenses (in $) in United States in 2009?
Ensure brevity in your answer.  -3.69e+12. What is the difference between the Expenses (in $) in Burkina Faso in 2007 and the Expenses (in $) in Russian Federation in 2009?
Offer a very short reply. -1.16e+13. What is the difference between the Expenses (in $) of Burkina Faso in 2007 and the Expenses (in $) of United States in 2009?
Give a very brief answer. -3.25e+12. What is the difference between the Expenses (in $) in Russian Federation in 2007 and the Expenses (in $) in United States in 2009?
Offer a terse response. 3.95e+12. What is the difference between the Expenses (in $) of Antigua and Barbuda in 2008 and the Expenses (in $) of Burkina Faso in 2009?
Your response must be concise. -4.98e+11. What is the difference between the Expenses (in $) of Antigua and Barbuda in 2008 and the Expenses (in $) of Russian Federation in 2009?
Your response must be concise. -1.21e+13. What is the difference between the Expenses (in $) of Antigua and Barbuda in 2008 and the Expenses (in $) of United States in 2009?
Provide a short and direct response. -3.69e+12. What is the difference between the Expenses (in $) in Burkina Faso in 2008 and the Expenses (in $) in Russian Federation in 2009?
Keep it short and to the point. -1.16e+13. What is the difference between the Expenses (in $) of Burkina Faso in 2008 and the Expenses (in $) of United States in 2009?
Offer a terse response. -3.24e+12. What is the difference between the Expenses (in $) in Russian Federation in 2008 and the Expenses (in $) in United States in 2009?
Provide a succinct answer. 5.19e+12. What is the average Expenses (in $) in Antigua and Barbuda per year?
Your answer should be compact. 6.43e+08. What is the average Expenses (in $) in Burkina Faso per year?
Offer a very short reply. 3.65e+11. What is the average Expenses (in $) of Russian Federation per year?
Provide a succinct answer. 5.91e+12. What is the average Expenses (in $) in United States per year?
Make the answer very short. 2.82e+12. In the year 2002, what is the difference between the Expenses (in $) of Antigua and Barbuda and Expenses (in $) of Burkina Faso?
Provide a succinct answer. -2.49e+11. In the year 2002, what is the difference between the Expenses (in $) of Antigua and Barbuda and Expenses (in $) of Russian Federation?
Make the answer very short. -2.44e+12. In the year 2002, what is the difference between the Expenses (in $) of Antigua and Barbuda and Expenses (in $) of United States?
Give a very brief answer. -2.19e+12. In the year 2002, what is the difference between the Expenses (in $) of Burkina Faso and Expenses (in $) of Russian Federation?
Give a very brief answer. -2.19e+12. In the year 2002, what is the difference between the Expenses (in $) of Burkina Faso and Expenses (in $) of United States?
Give a very brief answer. -1.94e+12. In the year 2002, what is the difference between the Expenses (in $) in Russian Federation and Expenses (in $) in United States?
Provide a short and direct response. 2.51e+11. In the year 2003, what is the difference between the Expenses (in $) of Antigua and Barbuda and Expenses (in $) of Burkina Faso?
Provide a succinct answer. -2.55e+11. In the year 2003, what is the difference between the Expenses (in $) of Antigua and Barbuda and Expenses (in $) of Russian Federation?
Make the answer very short. -3.04e+12. In the year 2003, what is the difference between the Expenses (in $) of Antigua and Barbuda and Expenses (in $) of United States?
Give a very brief answer. -2.36e+12. In the year 2003, what is the difference between the Expenses (in $) in Burkina Faso and Expenses (in $) in Russian Federation?
Make the answer very short. -2.79e+12. In the year 2003, what is the difference between the Expenses (in $) of Burkina Faso and Expenses (in $) of United States?
Your response must be concise. -2.11e+12. In the year 2003, what is the difference between the Expenses (in $) in Russian Federation and Expenses (in $) in United States?
Give a very brief answer. 6.83e+11. In the year 2004, what is the difference between the Expenses (in $) in Antigua and Barbuda and Expenses (in $) in Burkina Faso?
Your answer should be very brief. -2.92e+11. In the year 2004, what is the difference between the Expenses (in $) of Antigua and Barbuda and Expenses (in $) of Russian Federation?
Make the answer very short. -3.67e+12. In the year 2004, what is the difference between the Expenses (in $) of Antigua and Barbuda and Expenses (in $) of United States?
Make the answer very short. -2.49e+12. In the year 2004, what is the difference between the Expenses (in $) in Burkina Faso and Expenses (in $) in Russian Federation?
Your answer should be very brief. -3.38e+12. In the year 2004, what is the difference between the Expenses (in $) of Burkina Faso and Expenses (in $) of United States?
Your answer should be very brief. -2.20e+12. In the year 2004, what is the difference between the Expenses (in $) in Russian Federation and Expenses (in $) in United States?
Give a very brief answer. 1.18e+12. In the year 2005, what is the difference between the Expenses (in $) of Antigua and Barbuda and Expenses (in $) of Burkina Faso?
Give a very brief answer. -3.30e+11. In the year 2005, what is the difference between the Expenses (in $) of Antigua and Barbuda and Expenses (in $) of Russian Federation?
Provide a short and direct response. -4.31e+12. In the year 2005, what is the difference between the Expenses (in $) of Antigua and Barbuda and Expenses (in $) of United States?
Ensure brevity in your answer.  -2.70e+12. In the year 2005, what is the difference between the Expenses (in $) in Burkina Faso and Expenses (in $) in Russian Federation?
Offer a terse response. -3.98e+12. In the year 2005, what is the difference between the Expenses (in $) in Burkina Faso and Expenses (in $) in United States?
Your answer should be compact. -2.37e+12. In the year 2005, what is the difference between the Expenses (in $) in Russian Federation and Expenses (in $) in United States?
Your response must be concise. 1.61e+12. In the year 2006, what is the difference between the Expenses (in $) of Antigua and Barbuda and Expenses (in $) of Burkina Faso?
Ensure brevity in your answer.  -3.85e+11. In the year 2006, what is the difference between the Expenses (in $) in Antigua and Barbuda and Expenses (in $) in Russian Federation?
Your answer should be compact. -5.25e+12. In the year 2006, what is the difference between the Expenses (in $) of Antigua and Barbuda and Expenses (in $) of United States?
Your response must be concise. -2.84e+12. In the year 2006, what is the difference between the Expenses (in $) in Burkina Faso and Expenses (in $) in Russian Federation?
Provide a succinct answer. -4.86e+12. In the year 2006, what is the difference between the Expenses (in $) of Burkina Faso and Expenses (in $) of United States?
Your answer should be very brief. -2.45e+12. In the year 2006, what is the difference between the Expenses (in $) of Russian Federation and Expenses (in $) of United States?
Your answer should be compact. 2.41e+12. In the year 2007, what is the difference between the Expenses (in $) of Antigua and Barbuda and Expenses (in $) of Burkina Faso?
Ensure brevity in your answer.  -4.49e+11. In the year 2007, what is the difference between the Expenses (in $) in Antigua and Barbuda and Expenses (in $) in Russian Federation?
Offer a very short reply. -7.65e+12. In the year 2007, what is the difference between the Expenses (in $) in Antigua and Barbuda and Expenses (in $) in United States?
Your answer should be very brief. -3.01e+12. In the year 2007, what is the difference between the Expenses (in $) in Burkina Faso and Expenses (in $) in Russian Federation?
Make the answer very short. -7.20e+12. In the year 2007, what is the difference between the Expenses (in $) in Burkina Faso and Expenses (in $) in United States?
Ensure brevity in your answer.  -2.56e+12. In the year 2007, what is the difference between the Expenses (in $) of Russian Federation and Expenses (in $) of United States?
Offer a very short reply. 4.64e+12. In the year 2008, what is the difference between the Expenses (in $) of Antigua and Barbuda and Expenses (in $) of Burkina Faso?
Give a very brief answer. -4.53e+11. In the year 2008, what is the difference between the Expenses (in $) of Antigua and Barbuda and Expenses (in $) of Russian Federation?
Your answer should be compact. -8.89e+12. In the year 2008, what is the difference between the Expenses (in $) in Antigua and Barbuda and Expenses (in $) in United States?
Your answer should be very brief. -3.29e+12. In the year 2008, what is the difference between the Expenses (in $) in Burkina Faso and Expenses (in $) in Russian Federation?
Your response must be concise. -8.43e+12. In the year 2008, what is the difference between the Expenses (in $) of Burkina Faso and Expenses (in $) of United States?
Your answer should be compact. -2.84e+12. In the year 2008, what is the difference between the Expenses (in $) of Russian Federation and Expenses (in $) of United States?
Your response must be concise. 5.59e+12. In the year 2009, what is the difference between the Expenses (in $) in Antigua and Barbuda and Expenses (in $) in Burkina Faso?
Ensure brevity in your answer.  -4.98e+11. In the year 2009, what is the difference between the Expenses (in $) of Antigua and Barbuda and Expenses (in $) of Russian Federation?
Your answer should be very brief. -1.21e+13. In the year 2009, what is the difference between the Expenses (in $) in Antigua and Barbuda and Expenses (in $) in United States?
Ensure brevity in your answer.  -3.69e+12. In the year 2009, what is the difference between the Expenses (in $) in Burkina Faso and Expenses (in $) in Russian Federation?
Keep it short and to the point. -1.16e+13. In the year 2009, what is the difference between the Expenses (in $) in Burkina Faso and Expenses (in $) in United States?
Provide a short and direct response. -3.20e+12. In the year 2009, what is the difference between the Expenses (in $) in Russian Federation and Expenses (in $) in United States?
Your answer should be compact. 8.37e+12. What is the ratio of the Expenses (in $) in Antigua and Barbuda in 2002 to that in 2003?
Keep it short and to the point. 1.1. What is the ratio of the Expenses (in $) of Burkina Faso in 2002 to that in 2003?
Provide a short and direct response. 0.98. What is the ratio of the Expenses (in $) in Russian Federation in 2002 to that in 2003?
Make the answer very short. 0.8. What is the ratio of the Expenses (in $) in United States in 2002 to that in 2003?
Give a very brief answer. 0.93. What is the ratio of the Expenses (in $) in Antigua and Barbuda in 2002 to that in 2004?
Your answer should be compact. 0.99. What is the ratio of the Expenses (in $) of Burkina Faso in 2002 to that in 2004?
Provide a succinct answer. 0.85. What is the ratio of the Expenses (in $) in Russian Federation in 2002 to that in 2004?
Keep it short and to the point. 0.66. What is the ratio of the Expenses (in $) of United States in 2002 to that in 2004?
Make the answer very short. 0.88. What is the ratio of the Expenses (in $) in Burkina Faso in 2002 to that in 2005?
Give a very brief answer. 0.76. What is the ratio of the Expenses (in $) of Russian Federation in 2002 to that in 2005?
Keep it short and to the point. 0.57. What is the ratio of the Expenses (in $) of United States in 2002 to that in 2005?
Your response must be concise. 0.81. What is the ratio of the Expenses (in $) of Antigua and Barbuda in 2002 to that in 2006?
Keep it short and to the point. 0.8. What is the ratio of the Expenses (in $) of Burkina Faso in 2002 to that in 2006?
Keep it short and to the point. 0.65. What is the ratio of the Expenses (in $) of Russian Federation in 2002 to that in 2006?
Keep it short and to the point. 0.47. What is the ratio of the Expenses (in $) of United States in 2002 to that in 2006?
Your answer should be very brief. 0.77. What is the ratio of the Expenses (in $) of Antigua and Barbuda in 2002 to that in 2007?
Offer a very short reply. 0.73. What is the ratio of the Expenses (in $) in Burkina Faso in 2002 to that in 2007?
Give a very brief answer. 0.56. What is the ratio of the Expenses (in $) of Russian Federation in 2002 to that in 2007?
Provide a succinct answer. 0.32. What is the ratio of the Expenses (in $) in United States in 2002 to that in 2007?
Keep it short and to the point. 0.73. What is the ratio of the Expenses (in $) in Antigua and Barbuda in 2002 to that in 2008?
Give a very brief answer. 0.71. What is the ratio of the Expenses (in $) of Burkina Faso in 2002 to that in 2008?
Offer a terse response. 0.55. What is the ratio of the Expenses (in $) in Russian Federation in 2002 to that in 2008?
Provide a short and direct response. 0.27. What is the ratio of the Expenses (in $) of United States in 2002 to that in 2008?
Offer a terse response. 0.66. What is the ratio of the Expenses (in $) in Antigua and Barbuda in 2002 to that in 2009?
Ensure brevity in your answer.  0.7. What is the ratio of the Expenses (in $) of Burkina Faso in 2002 to that in 2009?
Make the answer very short. 0.5. What is the ratio of the Expenses (in $) in Russian Federation in 2002 to that in 2009?
Give a very brief answer. 0.2. What is the ratio of the Expenses (in $) in United States in 2002 to that in 2009?
Keep it short and to the point. 0.59. What is the ratio of the Expenses (in $) of Antigua and Barbuda in 2003 to that in 2004?
Provide a succinct answer. 0.9. What is the ratio of the Expenses (in $) in Burkina Faso in 2003 to that in 2004?
Keep it short and to the point. 0.87. What is the ratio of the Expenses (in $) in Russian Federation in 2003 to that in 2004?
Offer a very short reply. 0.83. What is the ratio of the Expenses (in $) of United States in 2003 to that in 2004?
Make the answer very short. 0.95. What is the ratio of the Expenses (in $) of Antigua and Barbuda in 2003 to that in 2005?
Provide a succinct answer. 0.88. What is the ratio of the Expenses (in $) in Burkina Faso in 2003 to that in 2005?
Your answer should be very brief. 0.77. What is the ratio of the Expenses (in $) of Russian Federation in 2003 to that in 2005?
Offer a very short reply. 0.71. What is the ratio of the Expenses (in $) in United States in 2003 to that in 2005?
Provide a short and direct response. 0.88. What is the ratio of the Expenses (in $) in Antigua and Barbuda in 2003 to that in 2006?
Keep it short and to the point. 0.73. What is the ratio of the Expenses (in $) in Burkina Faso in 2003 to that in 2006?
Your answer should be very brief. 0.66. What is the ratio of the Expenses (in $) of Russian Federation in 2003 to that in 2006?
Ensure brevity in your answer.  0.58. What is the ratio of the Expenses (in $) of United States in 2003 to that in 2006?
Ensure brevity in your answer.  0.83. What is the ratio of the Expenses (in $) in Antigua and Barbuda in 2003 to that in 2007?
Your response must be concise. 0.66. What is the ratio of the Expenses (in $) in Burkina Faso in 2003 to that in 2007?
Ensure brevity in your answer.  0.57. What is the ratio of the Expenses (in $) of Russian Federation in 2003 to that in 2007?
Your answer should be compact. 0.4. What is the ratio of the Expenses (in $) in United States in 2003 to that in 2007?
Ensure brevity in your answer.  0.78. What is the ratio of the Expenses (in $) of Antigua and Barbuda in 2003 to that in 2008?
Ensure brevity in your answer.  0.65. What is the ratio of the Expenses (in $) in Burkina Faso in 2003 to that in 2008?
Offer a very short reply. 0.56. What is the ratio of the Expenses (in $) in Russian Federation in 2003 to that in 2008?
Give a very brief answer. 0.34. What is the ratio of the Expenses (in $) in United States in 2003 to that in 2008?
Give a very brief answer. 0.72. What is the ratio of the Expenses (in $) of Antigua and Barbuda in 2003 to that in 2009?
Provide a succinct answer. 0.64. What is the ratio of the Expenses (in $) of Burkina Faso in 2003 to that in 2009?
Your response must be concise. 0.51. What is the ratio of the Expenses (in $) of Russian Federation in 2003 to that in 2009?
Your answer should be very brief. 0.25. What is the ratio of the Expenses (in $) in United States in 2003 to that in 2009?
Give a very brief answer. 0.64. What is the ratio of the Expenses (in $) of Antigua and Barbuda in 2004 to that in 2005?
Give a very brief answer. 0.98. What is the ratio of the Expenses (in $) in Burkina Faso in 2004 to that in 2005?
Your response must be concise. 0.89. What is the ratio of the Expenses (in $) of Russian Federation in 2004 to that in 2005?
Your response must be concise. 0.85. What is the ratio of the Expenses (in $) of United States in 2004 to that in 2005?
Provide a succinct answer. 0.92. What is the ratio of the Expenses (in $) in Antigua and Barbuda in 2004 to that in 2006?
Your answer should be compact. 0.81. What is the ratio of the Expenses (in $) in Burkina Faso in 2004 to that in 2006?
Provide a succinct answer. 0.76. What is the ratio of the Expenses (in $) in Russian Federation in 2004 to that in 2006?
Ensure brevity in your answer.  0.7. What is the ratio of the Expenses (in $) of United States in 2004 to that in 2006?
Your answer should be very brief. 0.88. What is the ratio of the Expenses (in $) in Antigua and Barbuda in 2004 to that in 2007?
Ensure brevity in your answer.  0.74. What is the ratio of the Expenses (in $) in Burkina Faso in 2004 to that in 2007?
Offer a very short reply. 0.65. What is the ratio of the Expenses (in $) of Russian Federation in 2004 to that in 2007?
Provide a short and direct response. 0.48. What is the ratio of the Expenses (in $) of United States in 2004 to that in 2007?
Keep it short and to the point. 0.83. What is the ratio of the Expenses (in $) of Antigua and Barbuda in 2004 to that in 2008?
Keep it short and to the point. 0.72. What is the ratio of the Expenses (in $) of Burkina Faso in 2004 to that in 2008?
Provide a short and direct response. 0.65. What is the ratio of the Expenses (in $) in Russian Federation in 2004 to that in 2008?
Keep it short and to the point. 0.41. What is the ratio of the Expenses (in $) of United States in 2004 to that in 2008?
Your response must be concise. 0.76. What is the ratio of the Expenses (in $) in Antigua and Barbuda in 2004 to that in 2009?
Make the answer very short. 0.71. What is the ratio of the Expenses (in $) in Burkina Faso in 2004 to that in 2009?
Keep it short and to the point. 0.59. What is the ratio of the Expenses (in $) of Russian Federation in 2004 to that in 2009?
Your response must be concise. 0.3. What is the ratio of the Expenses (in $) of United States in 2004 to that in 2009?
Provide a succinct answer. 0.67. What is the ratio of the Expenses (in $) of Antigua and Barbuda in 2005 to that in 2006?
Offer a very short reply. 0.82. What is the ratio of the Expenses (in $) in Burkina Faso in 2005 to that in 2006?
Provide a succinct answer. 0.86. What is the ratio of the Expenses (in $) of Russian Federation in 2005 to that in 2006?
Make the answer very short. 0.82. What is the ratio of the Expenses (in $) in United States in 2005 to that in 2006?
Provide a short and direct response. 0.95. What is the ratio of the Expenses (in $) of Antigua and Barbuda in 2005 to that in 2007?
Your answer should be very brief. 0.75. What is the ratio of the Expenses (in $) of Burkina Faso in 2005 to that in 2007?
Provide a succinct answer. 0.74. What is the ratio of the Expenses (in $) in Russian Federation in 2005 to that in 2007?
Offer a terse response. 0.56. What is the ratio of the Expenses (in $) of United States in 2005 to that in 2007?
Your answer should be very brief. 0.9. What is the ratio of the Expenses (in $) in Antigua and Barbuda in 2005 to that in 2008?
Your response must be concise. 0.74. What is the ratio of the Expenses (in $) in Burkina Faso in 2005 to that in 2008?
Ensure brevity in your answer.  0.73. What is the ratio of the Expenses (in $) in Russian Federation in 2005 to that in 2008?
Keep it short and to the point. 0.48. What is the ratio of the Expenses (in $) of United States in 2005 to that in 2008?
Your answer should be compact. 0.82. What is the ratio of the Expenses (in $) in Antigua and Barbuda in 2005 to that in 2009?
Your answer should be compact. 0.72. What is the ratio of the Expenses (in $) of Burkina Faso in 2005 to that in 2009?
Provide a short and direct response. 0.66. What is the ratio of the Expenses (in $) in Russian Federation in 2005 to that in 2009?
Your answer should be compact. 0.36. What is the ratio of the Expenses (in $) of United States in 2005 to that in 2009?
Your answer should be very brief. 0.73. What is the ratio of the Expenses (in $) in Antigua and Barbuda in 2006 to that in 2007?
Your answer should be compact. 0.91. What is the ratio of the Expenses (in $) in Burkina Faso in 2006 to that in 2007?
Give a very brief answer. 0.86. What is the ratio of the Expenses (in $) in Russian Federation in 2006 to that in 2007?
Ensure brevity in your answer.  0.69. What is the ratio of the Expenses (in $) in United States in 2006 to that in 2007?
Your answer should be compact. 0.94. What is the ratio of the Expenses (in $) in Antigua and Barbuda in 2006 to that in 2008?
Keep it short and to the point. 0.89. What is the ratio of the Expenses (in $) in Burkina Faso in 2006 to that in 2008?
Your response must be concise. 0.85. What is the ratio of the Expenses (in $) of Russian Federation in 2006 to that in 2008?
Make the answer very short. 0.59. What is the ratio of the Expenses (in $) of United States in 2006 to that in 2008?
Make the answer very short. 0.86. What is the ratio of the Expenses (in $) of Antigua and Barbuda in 2006 to that in 2009?
Provide a short and direct response. 0.88. What is the ratio of the Expenses (in $) of Burkina Faso in 2006 to that in 2009?
Offer a very short reply. 0.77. What is the ratio of the Expenses (in $) of Russian Federation in 2006 to that in 2009?
Provide a short and direct response. 0.44. What is the ratio of the Expenses (in $) in United States in 2006 to that in 2009?
Ensure brevity in your answer.  0.77. What is the ratio of the Expenses (in $) in Antigua and Barbuda in 2007 to that in 2008?
Keep it short and to the point. 0.98. What is the ratio of the Expenses (in $) of Russian Federation in 2007 to that in 2008?
Ensure brevity in your answer.  0.86. What is the ratio of the Expenses (in $) in United States in 2007 to that in 2008?
Your response must be concise. 0.91. What is the ratio of the Expenses (in $) of Antigua and Barbuda in 2007 to that in 2009?
Offer a very short reply. 0.96. What is the ratio of the Expenses (in $) of Burkina Faso in 2007 to that in 2009?
Offer a very short reply. 0.9. What is the ratio of the Expenses (in $) in Russian Federation in 2007 to that in 2009?
Provide a short and direct response. 0.63. What is the ratio of the Expenses (in $) of United States in 2007 to that in 2009?
Ensure brevity in your answer.  0.82. What is the ratio of the Expenses (in $) in Antigua and Barbuda in 2008 to that in 2009?
Ensure brevity in your answer.  0.98. What is the ratio of the Expenses (in $) in Burkina Faso in 2008 to that in 2009?
Offer a very short reply. 0.91. What is the ratio of the Expenses (in $) of Russian Federation in 2008 to that in 2009?
Your answer should be very brief. 0.74. What is the ratio of the Expenses (in $) in United States in 2008 to that in 2009?
Offer a very short reply. 0.89. What is the difference between the highest and the second highest Expenses (in $) of Antigua and Barbuda?
Make the answer very short. 1.54e+07. What is the difference between the highest and the second highest Expenses (in $) of Burkina Faso?
Your answer should be compact. 4.54e+1. What is the difference between the highest and the second highest Expenses (in $) of Russian Federation?
Your answer should be very brief. 3.18e+12. What is the difference between the highest and the second highest Expenses (in $) in United States?
Your answer should be compact. 4.00e+11. What is the difference between the highest and the lowest Expenses (in $) of Antigua and Barbuda?
Provide a succinct answer. 2.84e+08. What is the difference between the highest and the lowest Expenses (in $) in Burkina Faso?
Provide a succinct answer. 2.49e+11. What is the difference between the highest and the lowest Expenses (in $) in Russian Federation?
Keep it short and to the point. 9.62e+12. What is the difference between the highest and the lowest Expenses (in $) in United States?
Keep it short and to the point. 1.50e+12. 